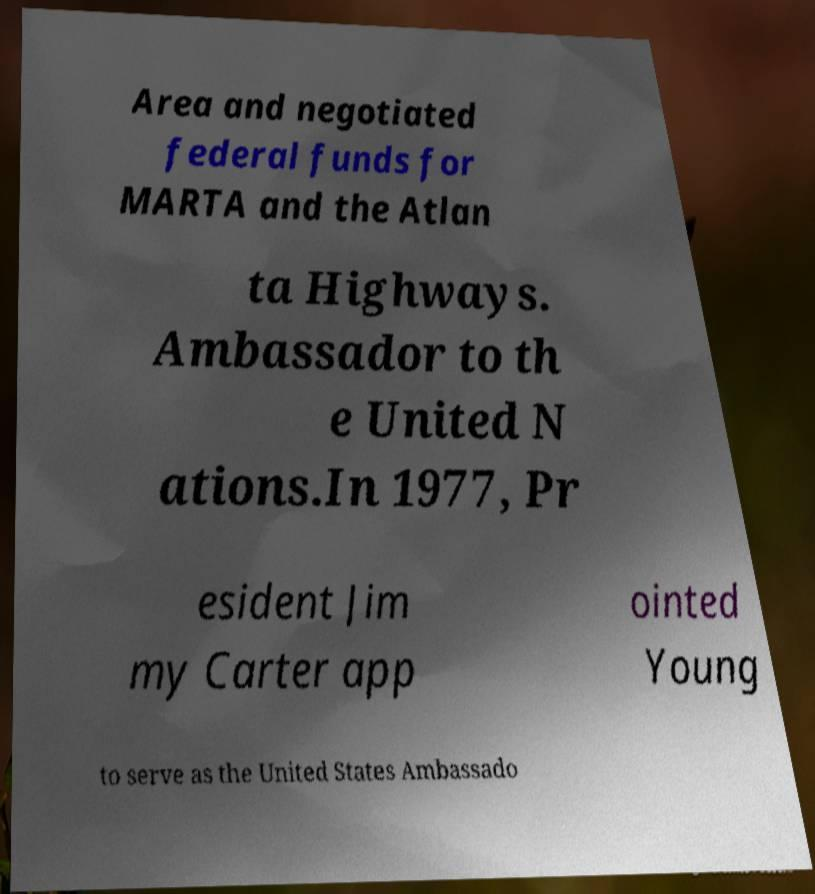Please identify and transcribe the text found in this image. Area and negotiated federal funds for MARTA and the Atlan ta Highways. Ambassador to th e United N ations.In 1977, Pr esident Jim my Carter app ointed Young to serve as the United States Ambassado 